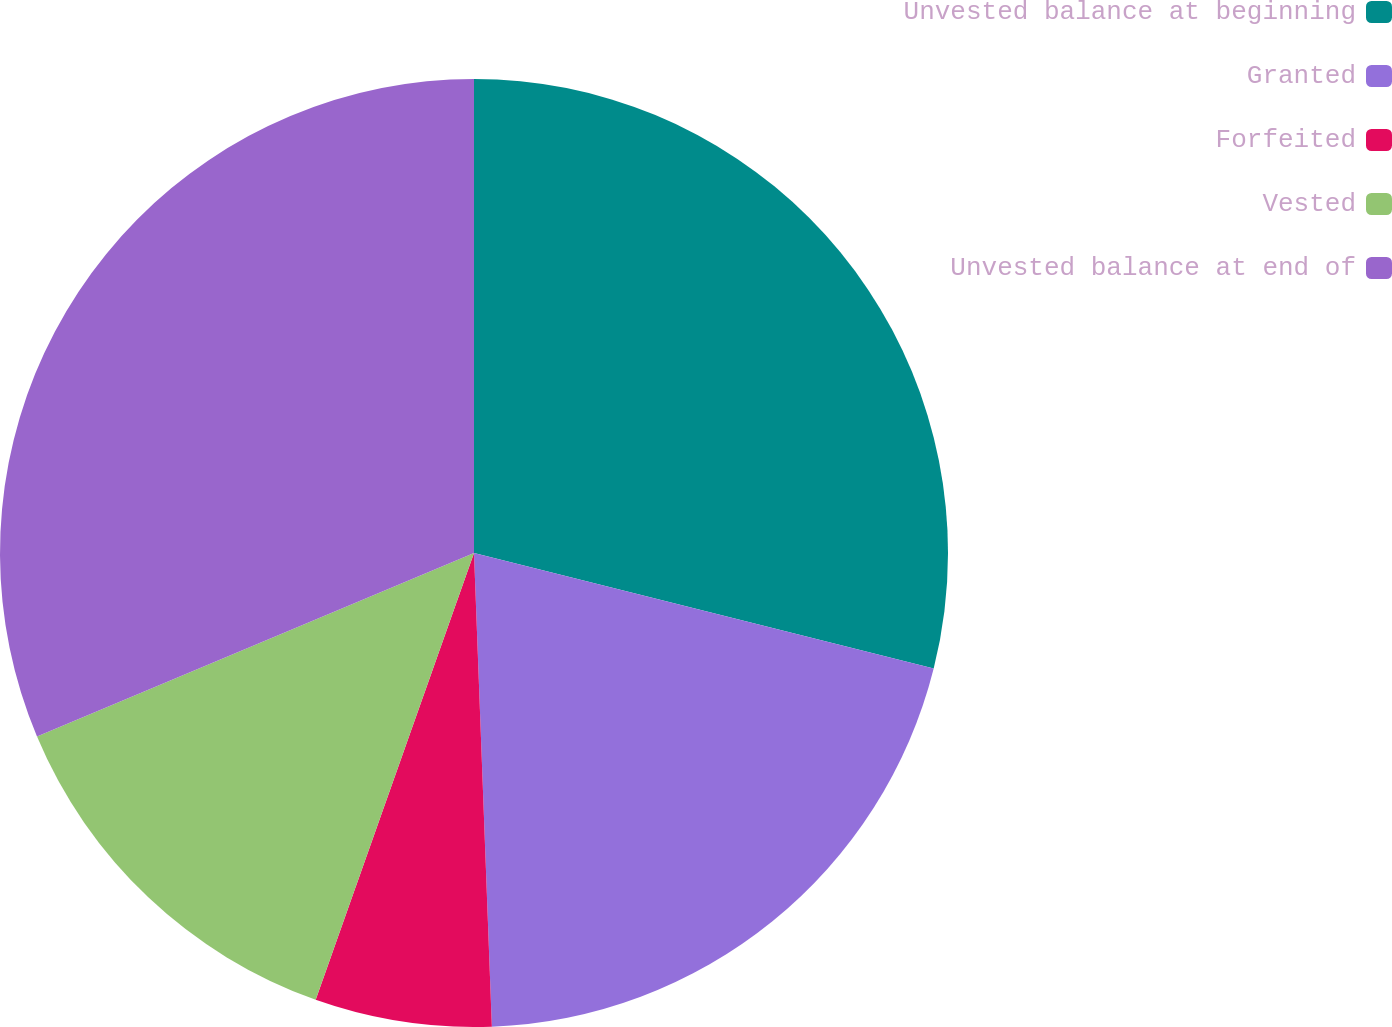Convert chart to OTSL. <chart><loc_0><loc_0><loc_500><loc_500><pie_chart><fcel>Unvested balance at beginning<fcel>Granted<fcel>Forfeited<fcel>Vested<fcel>Unvested balance at end of<nl><fcel>28.92%<fcel>20.48%<fcel>6.02%<fcel>13.25%<fcel>31.33%<nl></chart> 